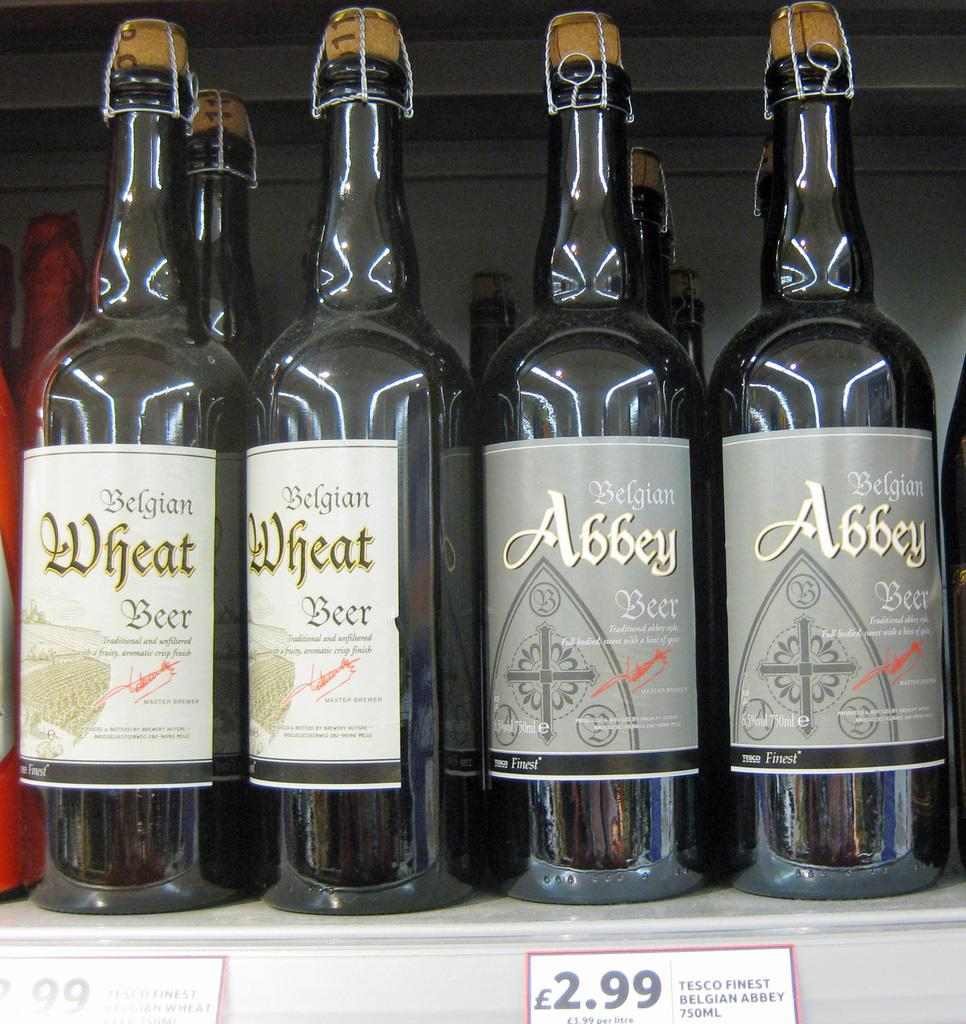<image>
Offer a succinct explanation of the picture presented. Four bottles of Belgian beer sitting on a shelf. 